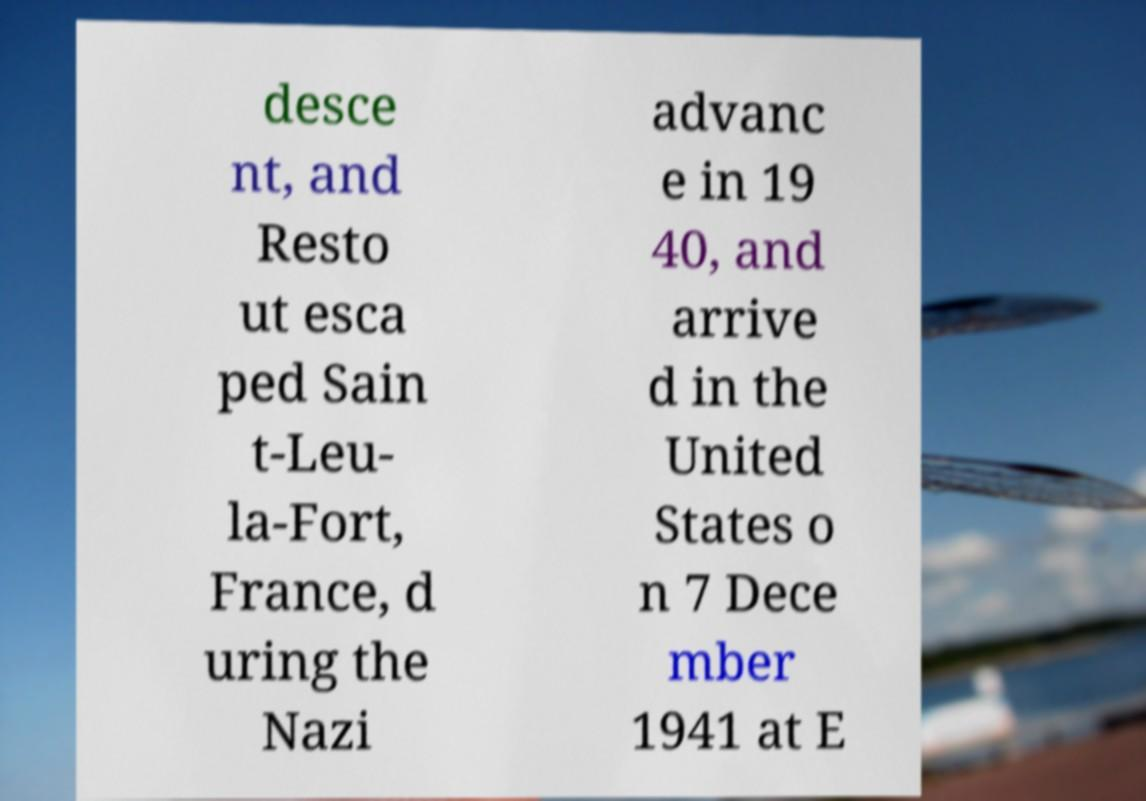Please identify and transcribe the text found in this image. desce nt, and Resto ut esca ped Sain t-Leu- la-Fort, France, d uring the Nazi advanc e in 19 40, and arrive d in the United States o n 7 Dece mber 1941 at E 